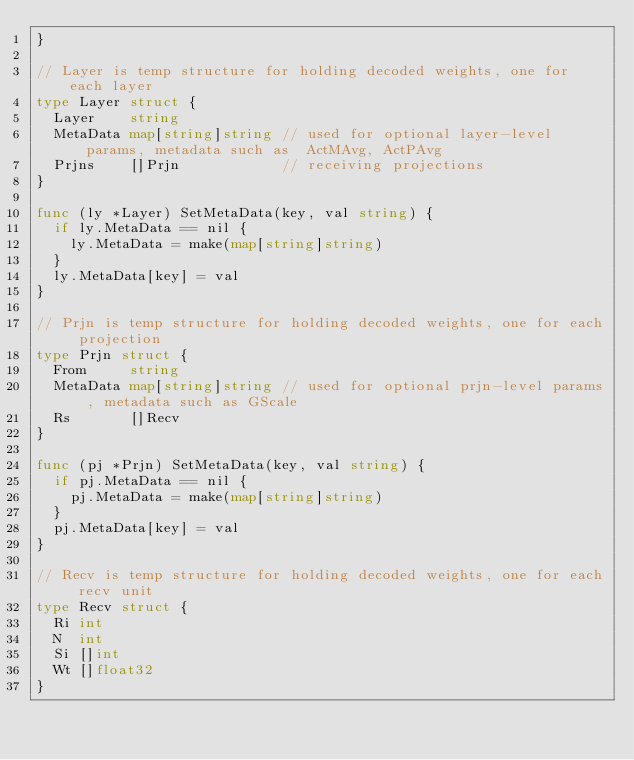<code> <loc_0><loc_0><loc_500><loc_500><_Go_>}

// Layer is temp structure for holding decoded weights, one for each layer
type Layer struct {
	Layer    string
	MetaData map[string]string // used for optional layer-level params, metadata such as 	ActMAvg, ActPAvg
	Prjns    []Prjn            // receiving projections
}

func (ly *Layer) SetMetaData(key, val string) {
	if ly.MetaData == nil {
		ly.MetaData = make(map[string]string)
	}
	ly.MetaData[key] = val
}

// Prjn is temp structure for holding decoded weights, one for each projection
type Prjn struct {
	From     string
	MetaData map[string]string // used for optional prjn-level params, metadata such as GScale
	Rs       []Recv
}

func (pj *Prjn) SetMetaData(key, val string) {
	if pj.MetaData == nil {
		pj.MetaData = make(map[string]string)
	}
	pj.MetaData[key] = val
}

// Recv is temp structure for holding decoded weights, one for each recv unit
type Recv struct {
	Ri int
	N  int
	Si []int
	Wt []float32
}
</code> 